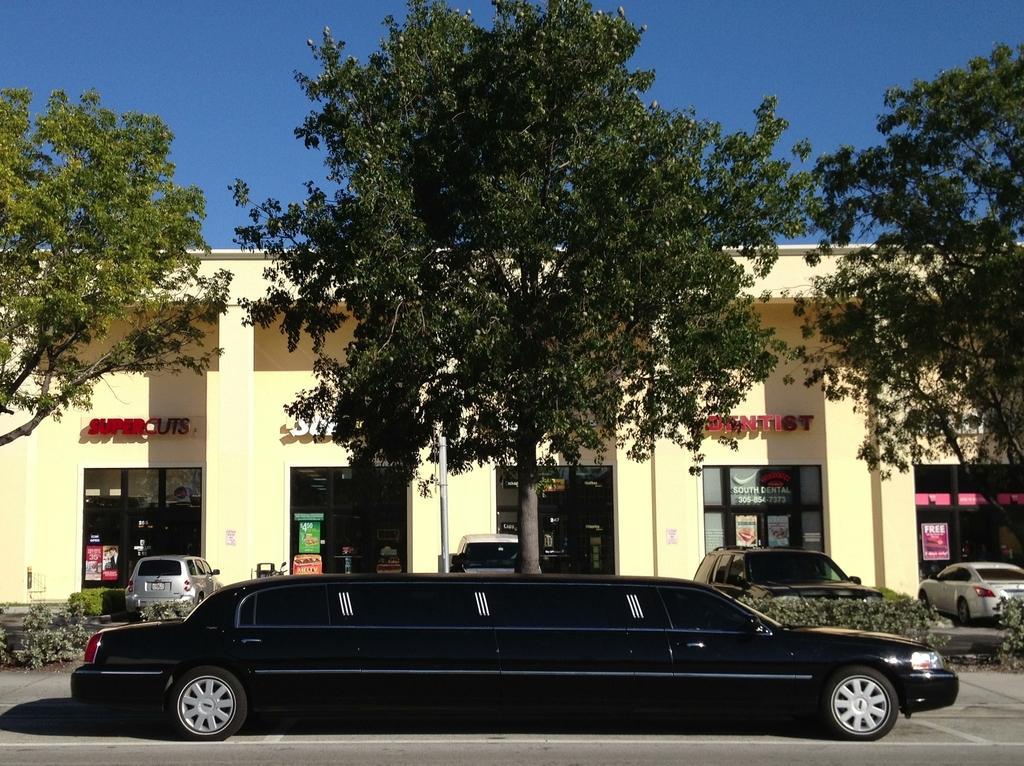How would you summarize this image in a sentence or two? In this picture we can see a building, stores, containers, poster on the doors, text on the wall, trees, board, cars, plants. At the bottom of the image we can see the road. At the top of the image we can see the sky. 